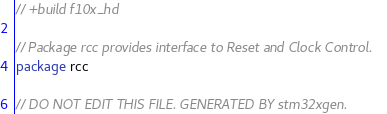Convert code to text. <code><loc_0><loc_0><loc_500><loc_500><_Go_>// +build f10x_hd

// Package rcc provides interface to Reset and Clock Control.
package rcc

// DO NOT EDIT THIS FILE. GENERATED BY stm32xgen.
</code> 